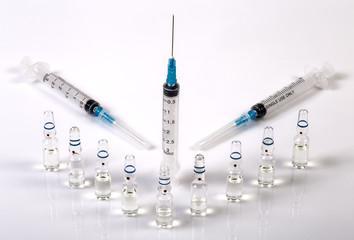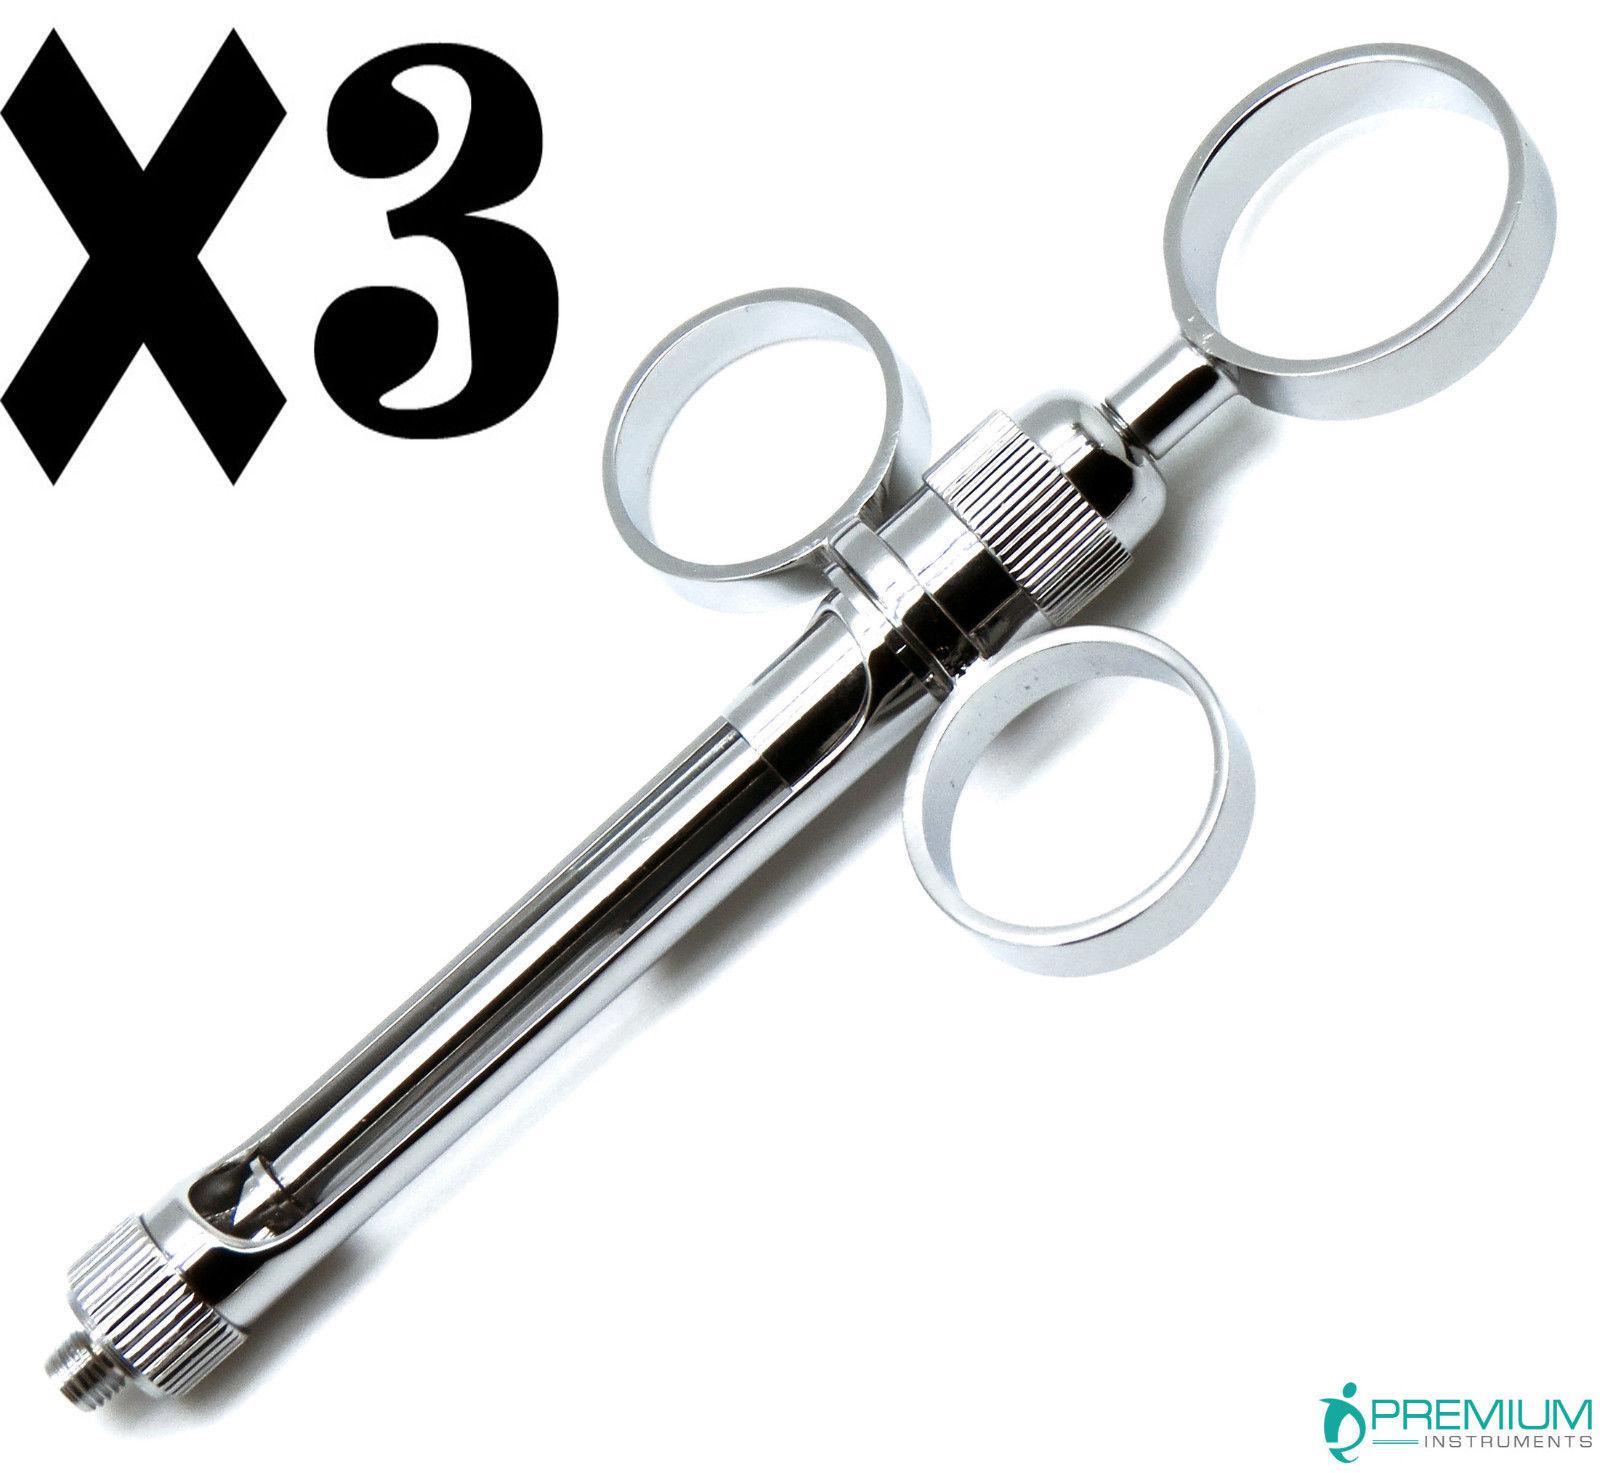The first image is the image on the left, the second image is the image on the right. For the images displayed, is the sentence "Three syringes lie on a surface near each other in the image on the left." factually correct? Answer yes or no. No. The first image is the image on the left, the second image is the image on the right. For the images shown, is this caption "An image includes syringes with green, red, and blue components." true? Answer yes or no. No. 